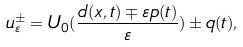Convert formula to latex. <formula><loc_0><loc_0><loc_500><loc_500>u _ { \varepsilon } ^ { \pm } = U _ { 0 } ( \frac { d ( x , t ) \mp \varepsilon p ( t ) } { \varepsilon } ) \pm q ( t ) ,</formula> 